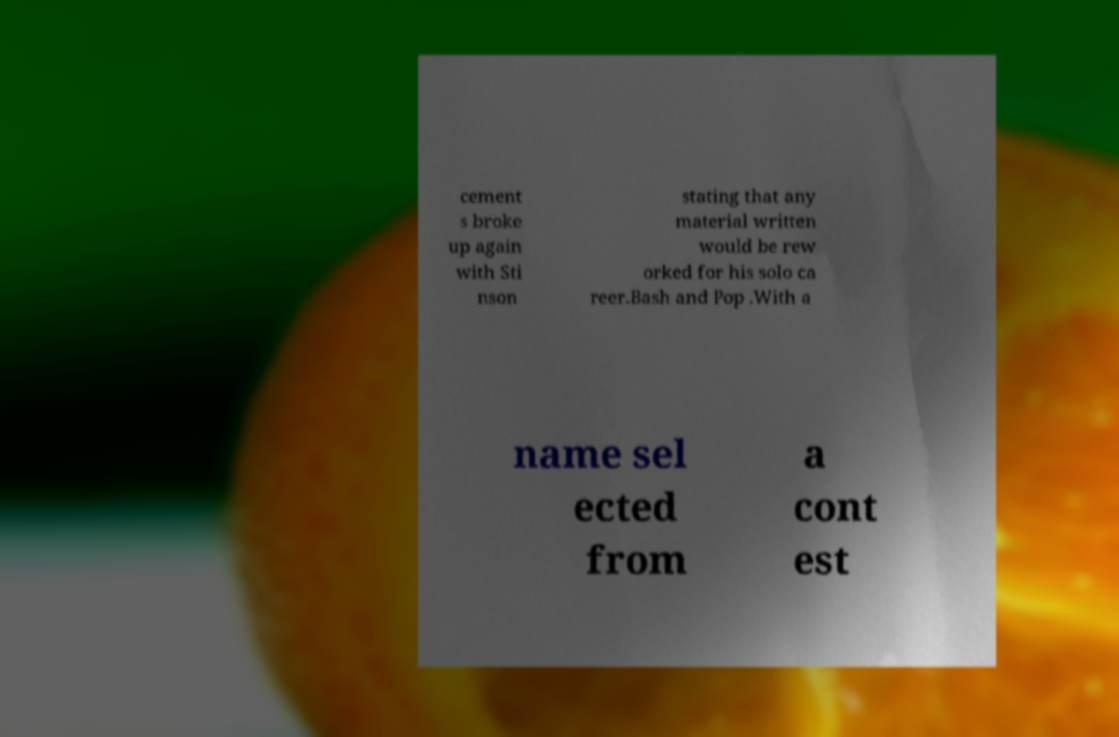What messages or text are displayed in this image? I need them in a readable, typed format. cement s broke up again with Sti nson stating that any material written would be rew orked for his solo ca reer.Bash and Pop .With a name sel ected from a cont est 